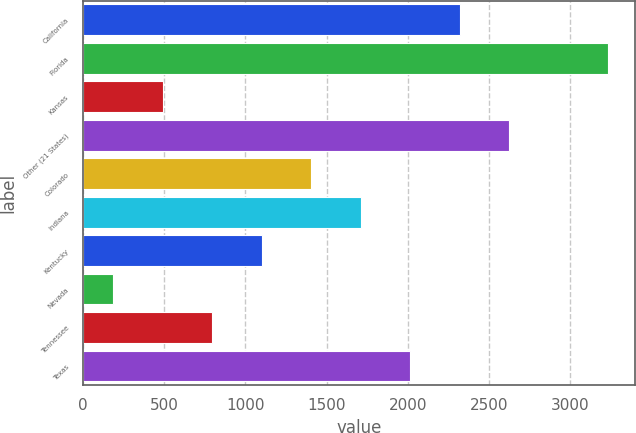<chart> <loc_0><loc_0><loc_500><loc_500><bar_chart><fcel>California<fcel>Florida<fcel>Kansas<fcel>Other (21 States)<fcel>Colorado<fcel>Indiana<fcel>Kentucky<fcel>Nevada<fcel>Tennessee<fcel>Texas<nl><fcel>2320.4<fcel>3236<fcel>489.2<fcel>2625.6<fcel>1404.8<fcel>1710<fcel>1099.6<fcel>184<fcel>794.4<fcel>2015.2<nl></chart> 